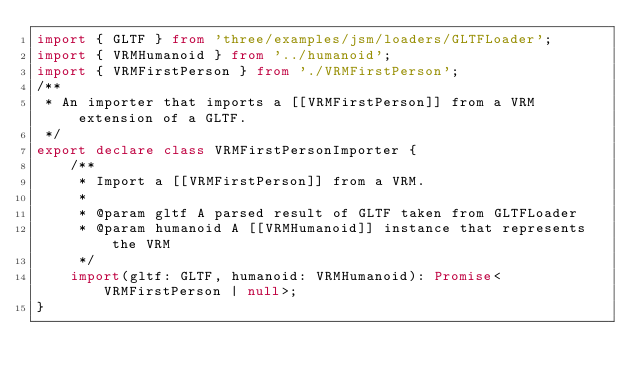Convert code to text. <code><loc_0><loc_0><loc_500><loc_500><_TypeScript_>import { GLTF } from 'three/examples/jsm/loaders/GLTFLoader';
import { VRMHumanoid } from '../humanoid';
import { VRMFirstPerson } from './VRMFirstPerson';
/**
 * An importer that imports a [[VRMFirstPerson]] from a VRM extension of a GLTF.
 */
export declare class VRMFirstPersonImporter {
    /**
     * Import a [[VRMFirstPerson]] from a VRM.
     *
     * @param gltf A parsed result of GLTF taken from GLTFLoader
     * @param humanoid A [[VRMHumanoid]] instance that represents the VRM
     */
    import(gltf: GLTF, humanoid: VRMHumanoid): Promise<VRMFirstPerson | null>;
}
</code> 